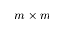<formula> <loc_0><loc_0><loc_500><loc_500>m \times m</formula> 